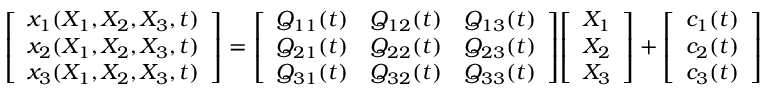<formula> <loc_0><loc_0><loc_500><loc_500>{ \left [ \begin{array} { l } { x _ { 1 } ( X _ { 1 } , X _ { 2 } , X _ { 3 } , t ) } \\ { x _ { 2 } ( X _ { 1 } , X _ { 2 } , X _ { 3 } , t ) } \\ { x _ { 3 } ( X _ { 1 } , X _ { 2 } , X _ { 3 } , t ) } \end{array} \right ] } = { \left [ \begin{array} { l l l } { Q _ { 1 1 } ( t ) } & { Q _ { 1 2 } ( t ) } & { Q _ { 1 3 } ( t ) } \\ { Q _ { 2 1 } ( t ) } & { Q _ { 2 2 } ( t ) } & { Q _ { 2 3 } ( t ) } \\ { Q _ { 3 1 } ( t ) } & { Q _ { 3 2 } ( t ) } & { Q _ { 3 3 } ( t ) } \end{array} \right ] } { \left [ \begin{array} { l } { X _ { 1 } } \\ { X _ { 2 } } \\ { X _ { 3 } } \end{array} \right ] } + { \left [ \begin{array} { l } { c _ { 1 } ( t ) } \\ { c _ { 2 } ( t ) } \\ { c _ { 3 } ( t ) } \end{array} \right ] }</formula> 